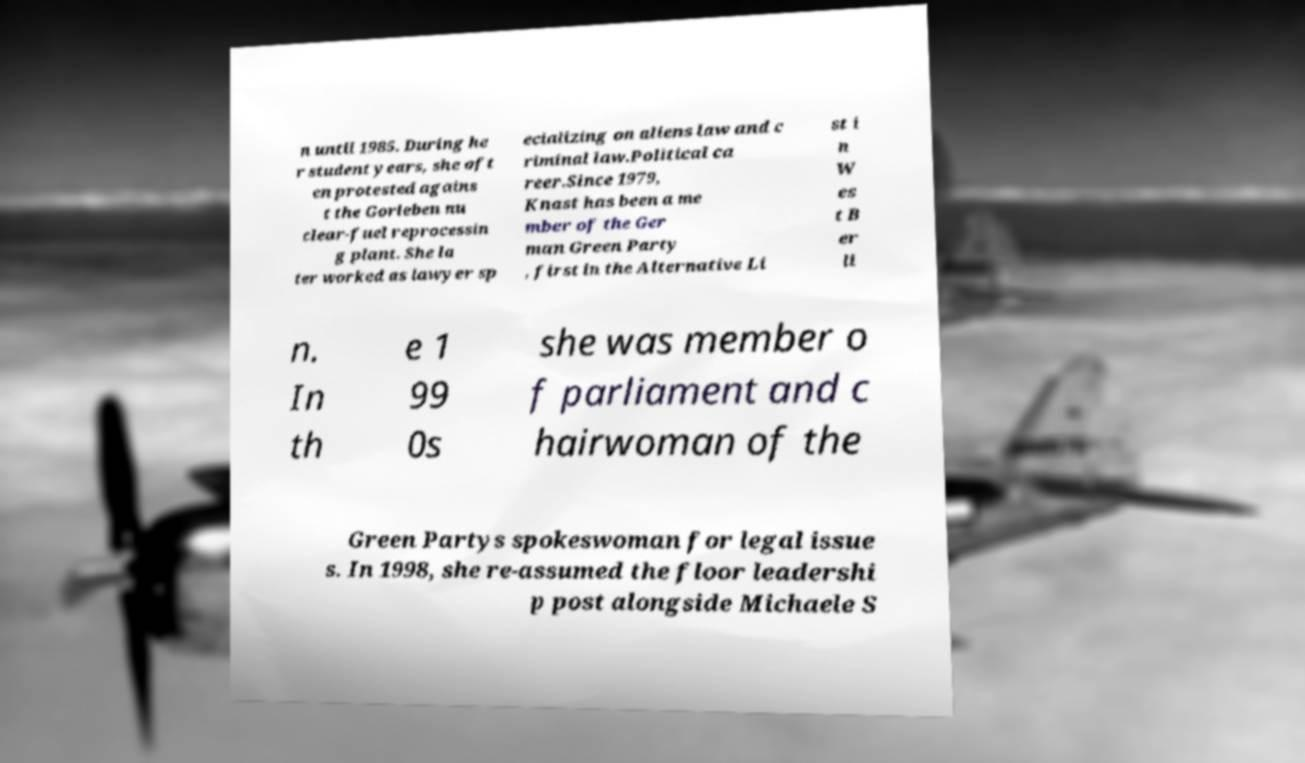I need the written content from this picture converted into text. Can you do that? n until 1985. During he r student years, she oft en protested agains t the Gorleben nu clear-fuel reprocessin g plant. She la ter worked as lawyer sp ecializing on aliens law and c riminal law.Political ca reer.Since 1979, Knast has been a me mber of the Ger man Green Party , first in the Alternative Li st i n W es t B er li n. In th e 1 99 0s she was member o f parliament and c hairwoman of the Green Partys spokeswoman for legal issue s. In 1998, she re-assumed the floor leadershi p post alongside Michaele S 